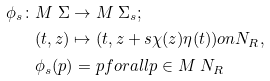Convert formula to latex. <formula><loc_0><loc_0><loc_500><loc_500>\phi _ { s } \colon & M \ \Sigma \rightarrow M \ \Sigma _ { s } ; \\ & ( t , z ) \mapsto ( t , z + s \chi ( z ) \eta ( t ) ) o n N _ { R } , \\ & \phi _ { s } ( p ) = p f o r a l l p \in M \ N _ { R }</formula> 